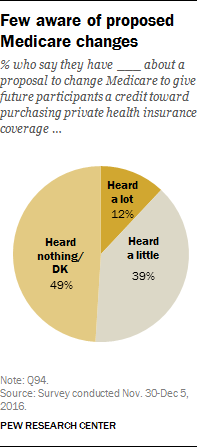Outline some significant characteristics in this image. I heard a little show in a pie chart with 39... The difference in value between 'Heard nothing/Dk' and 'Heard a little' is 10. 